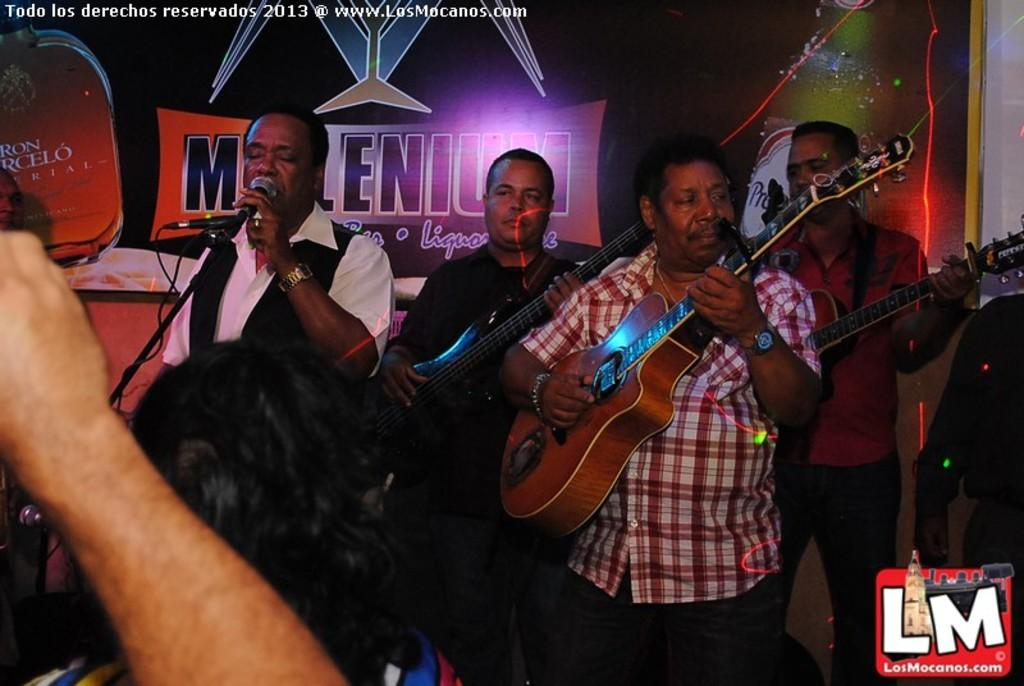How many people are in the image? There are persons in the image. What are the persons doing in the image? The persons are playing a guitar. What can be seen in the background of the image? There is a poster and a building in the background of the image. What type of star can be seen shining brightly in the image? There is no star visible in the image; it features persons playing a guitar with a poster and a building in the background. 